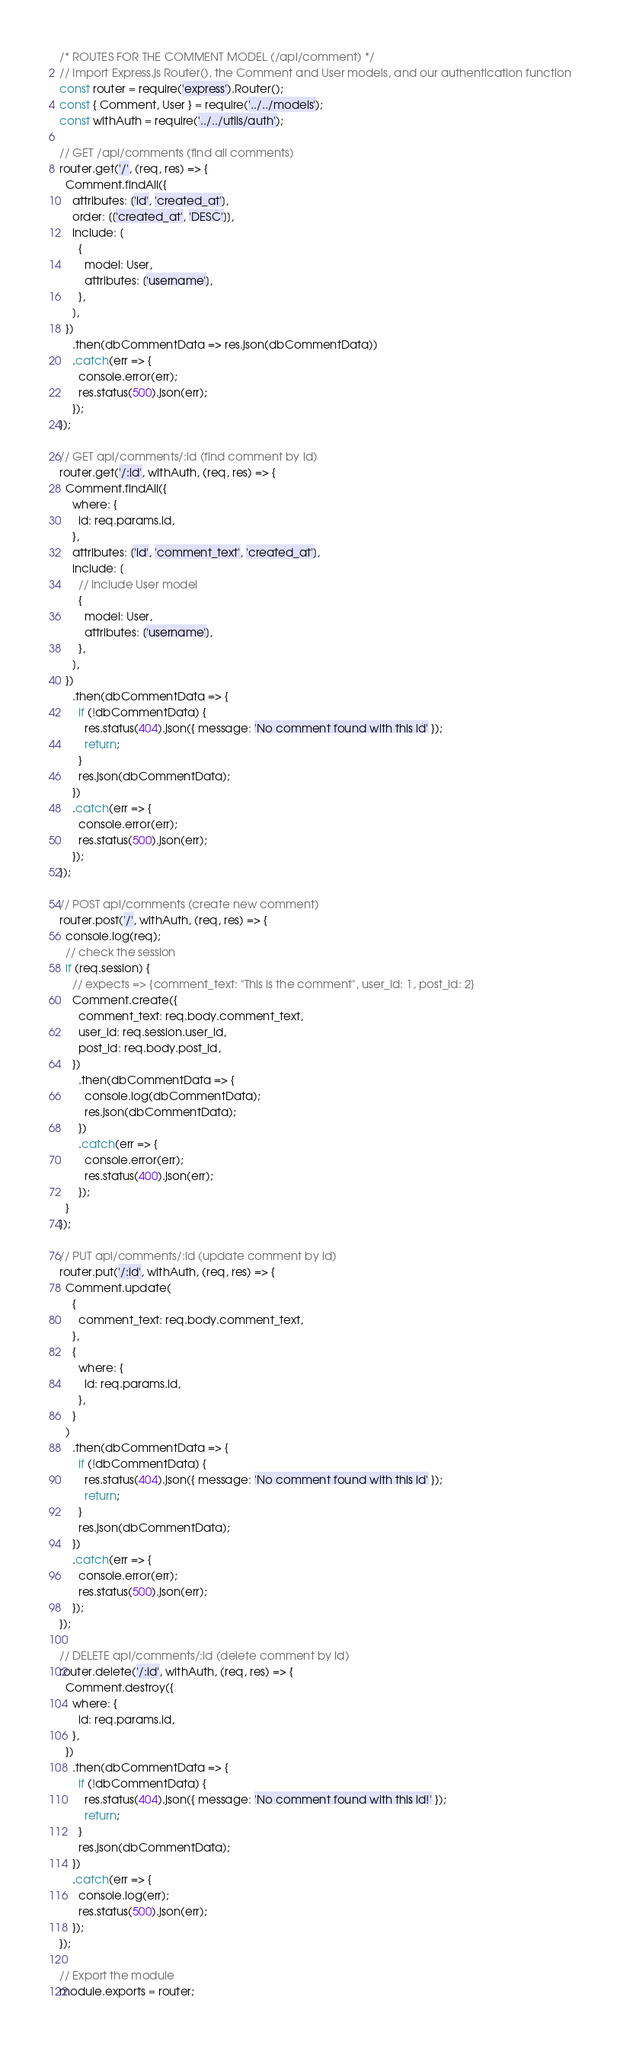<code> <loc_0><loc_0><loc_500><loc_500><_JavaScript_>/* ROUTES FOR THE COMMENT MODEL (/api/comment) */
// Import Express.js Router(), the Comment and User models, and our authentication function
const router = require('express').Router();
const { Comment, User } = require('../../models');
const withAuth = require('../../utils/auth');

// GET /api/comments (find all comments)
router.get('/', (req, res) => {
  Comment.findAll({
    attributes: ['id', 'created_at'],
    order: [['created_at', 'DESC']],
    include: [
      {
        model: User,
        attributes: ['username'],
      },
    ],
  })
    .then(dbCommentData => res.json(dbCommentData))
    .catch(err => {
      console.error(err);
      res.status(500).json(err);
    });
});

// GET api/comments/:id (find comment by id)
router.get('/:id', withAuth, (req, res) => {
  Comment.findAll({
    where: {
      id: req.params.id,
    },
    attributes: ['id', 'comment_text', 'created_at'],
    include: [
      // include User model
      {
        model: User,
        attributes: ['username'],
      },
    ],
  })
    .then(dbCommentData => {
      if (!dbCommentData) {
        res.status(404).json({ message: 'No comment found with this id' });
        return;
      }
      res.json(dbCommentData);
    })
    .catch(err => {
      console.error(err);
      res.status(500).json(err);
    });
});

// POST api/comments (create new comment)
router.post('/', withAuth, (req, res) => {
  console.log(req);
  // check the session
  if (req.session) {
    // expects => {comment_text: "This is the comment", user_id: 1, post_id: 2}
    Comment.create({
      comment_text: req.body.comment_text,
      user_id: req.session.user_id,
      post_id: req.body.post_id,
    })
      .then(dbCommentData => {
        console.log(dbCommentData);
        res.json(dbCommentData);
      })
      .catch(err => {
        console.error(err);
        res.status(400).json(err);
      });
  }
});

// PUT api/comments/:id (update comment by id)
router.put('/:id', withAuth, (req, res) => {
  Comment.update(
    {
      comment_text: req.body.comment_text,
    },
    {
      where: {
        id: req.params.id,
      },
    }
  )
    .then(dbCommentData => {
      if (!dbCommentData) {
        res.status(404).json({ message: 'No comment found with this id' });
        return;
      }
      res.json(dbCommentData);
    })
    .catch(err => {
      console.error(err);
      res.status(500).json(err);
    });
});

// DELETE api/comments/:id (delete comment by id)
router.delete('/:id', withAuth, (req, res) => {
  Comment.destroy({
    where: {
      id: req.params.id,
    },
  })
    .then(dbCommentData => {
      if (!dbCommentData) {
        res.status(404).json({ message: 'No comment found with this id!' });
        return;
      }
      res.json(dbCommentData);
    })
    .catch(err => {
      console.log(err);
      res.status(500).json(err);
    });
});

// Export the module
module.exports = router;
</code> 